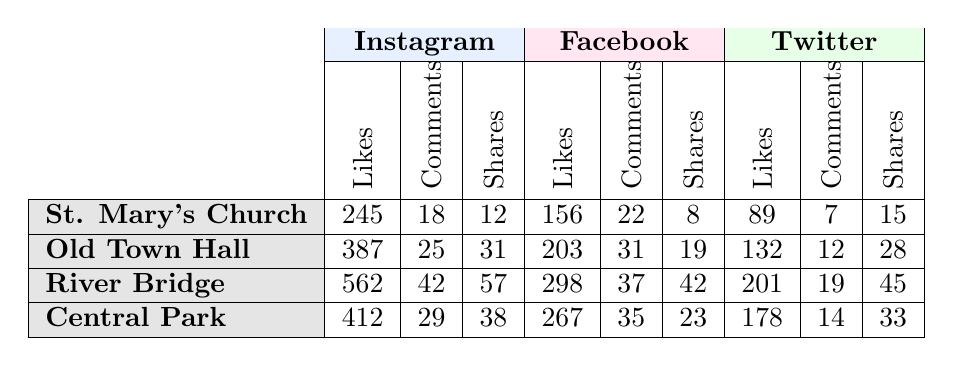What platform had the highest number of likes for the River Bridge? According to the table, Instagram had 562 likes for the River Bridge, which is higher than both Facebook's 298 and Twitter's 201 likes.
Answer: Instagram Which landmark received the most comments overall? By adding the comments for each landmark across all platforms: St. Mary's Church (18 + 22 + 7 = 47), Old Town Hall (25 + 31 + 12 = 68), River Bridge (42 + 37 + 19 = 98), and Central Park (29 + 35 + 14 = 78). The River Bridge has the highest total of 98 comments.
Answer: River Bridge Did Central Park have more shares on Facebook than on Twitter? Central Park received 23 shares on Facebook and 33 shares on Twitter. Since 23 is less than 33, the answer is No.
Answer: No What is the difference in the number of likes for St. Mary's Church between Instagram and Facebook? St. Mary's Church received 245 likes on Instagram and 156 likes on Facebook. The difference is 245 - 156 = 89 likes.
Answer: 89 What is the average number of likes for the Old Town Hall across all platforms? The likes for Old Town Hall are 387 (Instagram) + 203 (Facebook) + 132 (Twitter) = 722. There are 3 platforms, so the average is 722 / 3 = 240.67, which rounds to approximately 241.
Answer: 241 Which platform had the lowest engagement through shares for the Central Park landmark? The shares for Central Park are 38 (Instagram), 23 (Facebook), and 33 (Twitter). Facebook has the lowest engagement with 23 shares.
Answer: Facebook Which landmark received the highest number of total interactions (likes, comments, shares) on Instagram? To find total interactions for each landmark on Instagram, we sum likes, comments, and shares: St. Mary's Church (245 + 18 + 12 = 275), Old Town Hall (387 + 25 + 31 = 443), River Bridge (562 + 42 + 57 = 661), and Central Park (412 + 29 + 38 = 479). River Bridge has the highest total at 661.
Answer: River Bridge 